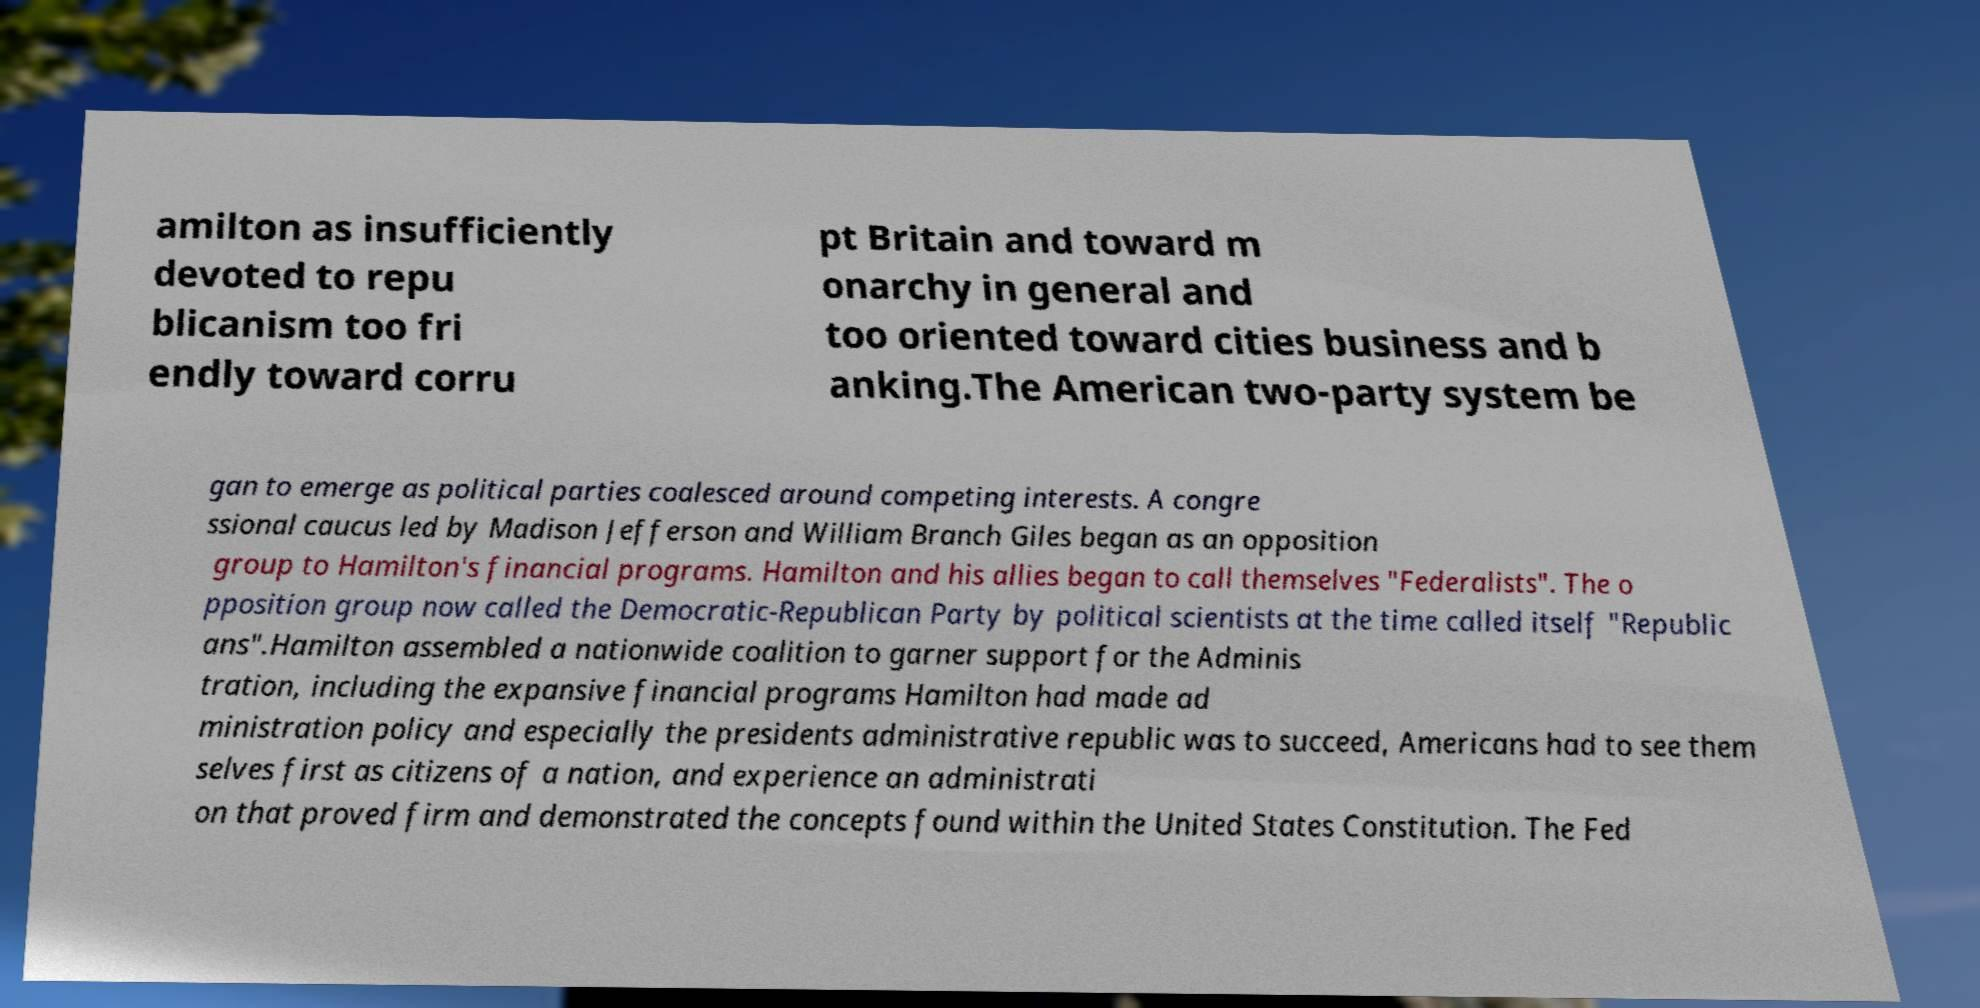I need the written content from this picture converted into text. Can you do that? amilton as insufficiently devoted to repu blicanism too fri endly toward corru pt Britain and toward m onarchy in general and too oriented toward cities business and b anking.The American two-party system be gan to emerge as political parties coalesced around competing interests. A congre ssional caucus led by Madison Jefferson and William Branch Giles began as an opposition group to Hamilton's financial programs. Hamilton and his allies began to call themselves "Federalists". The o pposition group now called the Democratic-Republican Party by political scientists at the time called itself "Republic ans".Hamilton assembled a nationwide coalition to garner support for the Adminis tration, including the expansive financial programs Hamilton had made ad ministration policy and especially the presidents administrative republic was to succeed, Americans had to see them selves first as citizens of a nation, and experience an administrati on that proved firm and demonstrated the concepts found within the United States Constitution. The Fed 